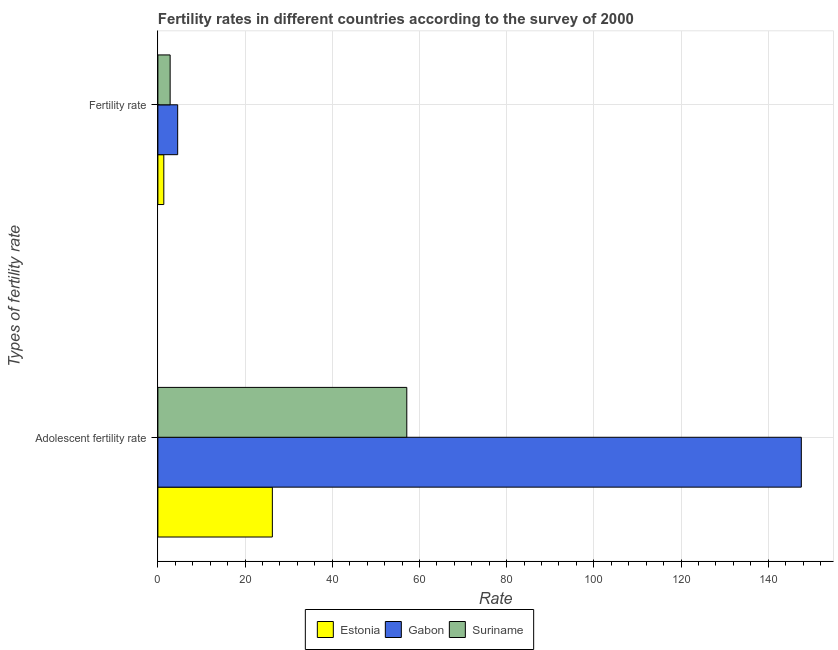Are the number of bars on each tick of the Y-axis equal?
Make the answer very short. Yes. How many bars are there on the 2nd tick from the bottom?
Offer a terse response. 3. What is the label of the 1st group of bars from the top?
Offer a terse response. Fertility rate. What is the fertility rate in Gabon?
Make the answer very short. 4.54. Across all countries, what is the maximum adolescent fertility rate?
Provide a short and direct response. 147.59. Across all countries, what is the minimum fertility rate?
Your answer should be compact. 1.36. In which country was the fertility rate maximum?
Offer a very short reply. Gabon. In which country was the fertility rate minimum?
Ensure brevity in your answer.  Estonia. What is the total adolescent fertility rate in the graph?
Give a very brief answer. 230.95. What is the difference between the adolescent fertility rate in Estonia and that in Suriname?
Provide a short and direct response. -30.84. What is the difference between the adolescent fertility rate in Estonia and the fertility rate in Suriname?
Keep it short and to the point. 23.45. What is the average adolescent fertility rate per country?
Offer a terse response. 76.98. What is the difference between the fertility rate and adolescent fertility rate in Estonia?
Offer a terse response. -24.9. In how many countries, is the fertility rate greater than 84 ?
Ensure brevity in your answer.  0. What is the ratio of the adolescent fertility rate in Suriname to that in Estonia?
Keep it short and to the point. 2.17. In how many countries, is the fertility rate greater than the average fertility rate taken over all countries?
Keep it short and to the point. 1. What does the 1st bar from the top in Fertility rate represents?
Provide a short and direct response. Suriname. What does the 1st bar from the bottom in Fertility rate represents?
Keep it short and to the point. Estonia. How many bars are there?
Give a very brief answer. 6. Are all the bars in the graph horizontal?
Offer a terse response. Yes. Are the values on the major ticks of X-axis written in scientific E-notation?
Ensure brevity in your answer.  No. Does the graph contain grids?
Offer a very short reply. Yes. How are the legend labels stacked?
Keep it short and to the point. Horizontal. What is the title of the graph?
Ensure brevity in your answer.  Fertility rates in different countries according to the survey of 2000. What is the label or title of the X-axis?
Your response must be concise. Rate. What is the label or title of the Y-axis?
Your answer should be very brief. Types of fertility rate. What is the Rate of Estonia in Adolescent fertility rate?
Ensure brevity in your answer.  26.26. What is the Rate in Gabon in Adolescent fertility rate?
Offer a very short reply. 147.59. What is the Rate of Suriname in Adolescent fertility rate?
Keep it short and to the point. 57.1. What is the Rate of Estonia in Fertility rate?
Ensure brevity in your answer.  1.36. What is the Rate of Gabon in Fertility rate?
Offer a very short reply. 4.54. What is the Rate in Suriname in Fertility rate?
Provide a succinct answer. 2.81. Across all Types of fertility rate, what is the maximum Rate of Estonia?
Offer a terse response. 26.26. Across all Types of fertility rate, what is the maximum Rate in Gabon?
Give a very brief answer. 147.59. Across all Types of fertility rate, what is the maximum Rate of Suriname?
Provide a short and direct response. 57.1. Across all Types of fertility rate, what is the minimum Rate of Estonia?
Offer a very short reply. 1.36. Across all Types of fertility rate, what is the minimum Rate in Gabon?
Offer a very short reply. 4.54. Across all Types of fertility rate, what is the minimum Rate of Suriname?
Keep it short and to the point. 2.81. What is the total Rate of Estonia in the graph?
Your response must be concise. 27.62. What is the total Rate of Gabon in the graph?
Your response must be concise. 152.13. What is the total Rate of Suriname in the graph?
Give a very brief answer. 59.91. What is the difference between the Rate in Estonia in Adolescent fertility rate and that in Fertility rate?
Your answer should be compact. 24.9. What is the difference between the Rate in Gabon in Adolescent fertility rate and that in Fertility rate?
Your answer should be compact. 143.05. What is the difference between the Rate of Suriname in Adolescent fertility rate and that in Fertility rate?
Your answer should be compact. 54.29. What is the difference between the Rate in Estonia in Adolescent fertility rate and the Rate in Gabon in Fertility rate?
Offer a terse response. 21.72. What is the difference between the Rate of Estonia in Adolescent fertility rate and the Rate of Suriname in Fertility rate?
Make the answer very short. 23.45. What is the difference between the Rate of Gabon in Adolescent fertility rate and the Rate of Suriname in Fertility rate?
Provide a succinct answer. 144.78. What is the average Rate of Estonia per Types of fertility rate?
Offer a terse response. 13.81. What is the average Rate in Gabon per Types of fertility rate?
Keep it short and to the point. 76.07. What is the average Rate of Suriname per Types of fertility rate?
Provide a short and direct response. 29.95. What is the difference between the Rate in Estonia and Rate in Gabon in Adolescent fertility rate?
Give a very brief answer. -121.33. What is the difference between the Rate in Estonia and Rate in Suriname in Adolescent fertility rate?
Your answer should be very brief. -30.84. What is the difference between the Rate of Gabon and Rate of Suriname in Adolescent fertility rate?
Offer a very short reply. 90.49. What is the difference between the Rate in Estonia and Rate in Gabon in Fertility rate?
Provide a succinct answer. -3.18. What is the difference between the Rate in Estonia and Rate in Suriname in Fertility rate?
Give a very brief answer. -1.45. What is the difference between the Rate in Gabon and Rate in Suriname in Fertility rate?
Keep it short and to the point. 1.73. What is the ratio of the Rate of Estonia in Adolescent fertility rate to that in Fertility rate?
Your answer should be very brief. 19.31. What is the ratio of the Rate in Gabon in Adolescent fertility rate to that in Fertility rate?
Offer a very short reply. 32.52. What is the ratio of the Rate in Suriname in Adolescent fertility rate to that in Fertility rate?
Ensure brevity in your answer.  20.32. What is the difference between the highest and the second highest Rate of Estonia?
Keep it short and to the point. 24.9. What is the difference between the highest and the second highest Rate in Gabon?
Make the answer very short. 143.05. What is the difference between the highest and the second highest Rate of Suriname?
Offer a terse response. 54.29. What is the difference between the highest and the lowest Rate of Estonia?
Your answer should be very brief. 24.9. What is the difference between the highest and the lowest Rate in Gabon?
Offer a very short reply. 143.05. What is the difference between the highest and the lowest Rate in Suriname?
Offer a terse response. 54.29. 